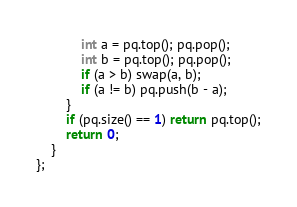Convert code to text. <code><loc_0><loc_0><loc_500><loc_500><_C++_>            int a = pq.top(); pq.pop();
            int b = pq.top(); pq.pop();
            if (a > b) swap(a, b);
            if (a != b) pq.push(b - a);
        }
        if (pq.size() == 1) return pq.top();
        return 0;
    }
};
</code> 